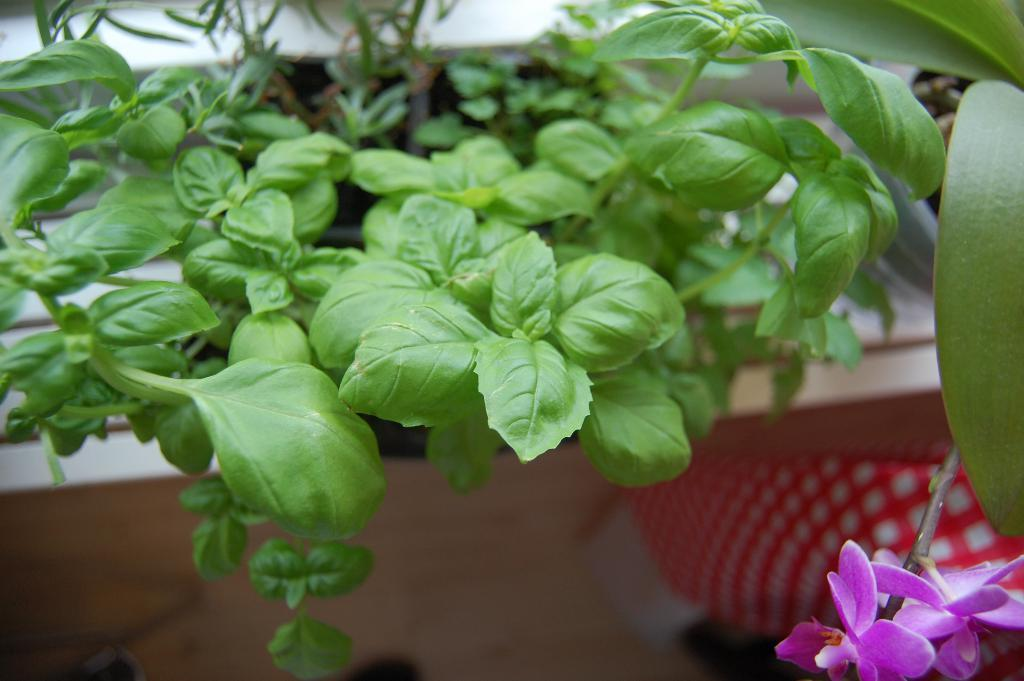What is the main subject of the image? The main subject of the image is a zoomed-in view of leafs. Are there any other elements present in the image besides the leafs? Yes, there is a pink color flower in the right bottom of the image. Can you describe the flower in the image? The flower has a stem. What type of chin can be seen on the leaf in the image? There is no chin present in the image, as it features a zoomed-in view of leafs and a flower. Is there any blood visible in the image? There is no blood present in the image. 